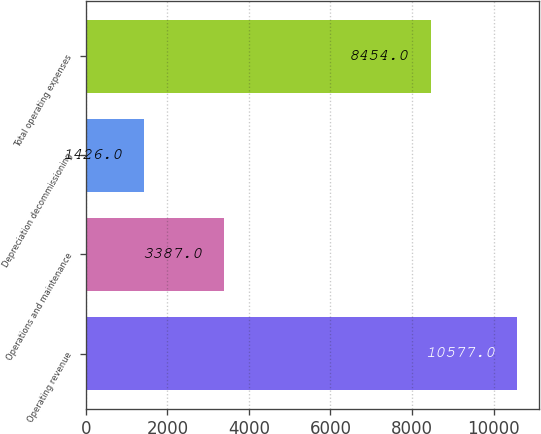Convert chart to OTSL. <chart><loc_0><loc_0><loc_500><loc_500><bar_chart><fcel>Operating revenue<fcel>Operations and maintenance<fcel>Depreciation decommissioning<fcel>Total operating expenses<nl><fcel>10577<fcel>3387<fcel>1426<fcel>8454<nl></chart> 